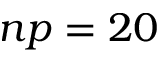Convert formula to latex. <formula><loc_0><loc_0><loc_500><loc_500>n p = 2 0</formula> 